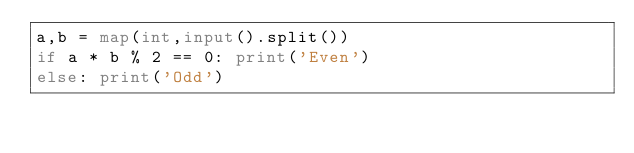<code> <loc_0><loc_0><loc_500><loc_500><_Python_>a,b = map(int,input().split())
if a * b % 2 == 0: print('Even')
else: print('Odd')</code> 